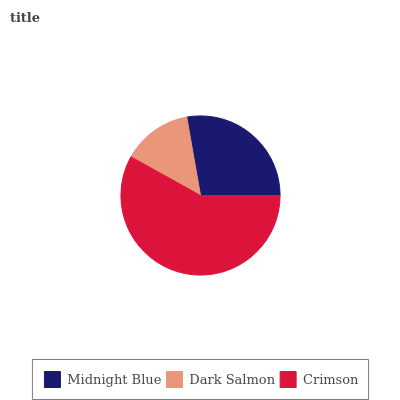Is Dark Salmon the minimum?
Answer yes or no. Yes. Is Crimson the maximum?
Answer yes or no. Yes. Is Crimson the minimum?
Answer yes or no. No. Is Dark Salmon the maximum?
Answer yes or no. No. Is Crimson greater than Dark Salmon?
Answer yes or no. Yes. Is Dark Salmon less than Crimson?
Answer yes or no. Yes. Is Dark Salmon greater than Crimson?
Answer yes or no. No. Is Crimson less than Dark Salmon?
Answer yes or no. No. Is Midnight Blue the high median?
Answer yes or no. Yes. Is Midnight Blue the low median?
Answer yes or no. Yes. Is Crimson the high median?
Answer yes or no. No. Is Crimson the low median?
Answer yes or no. No. 